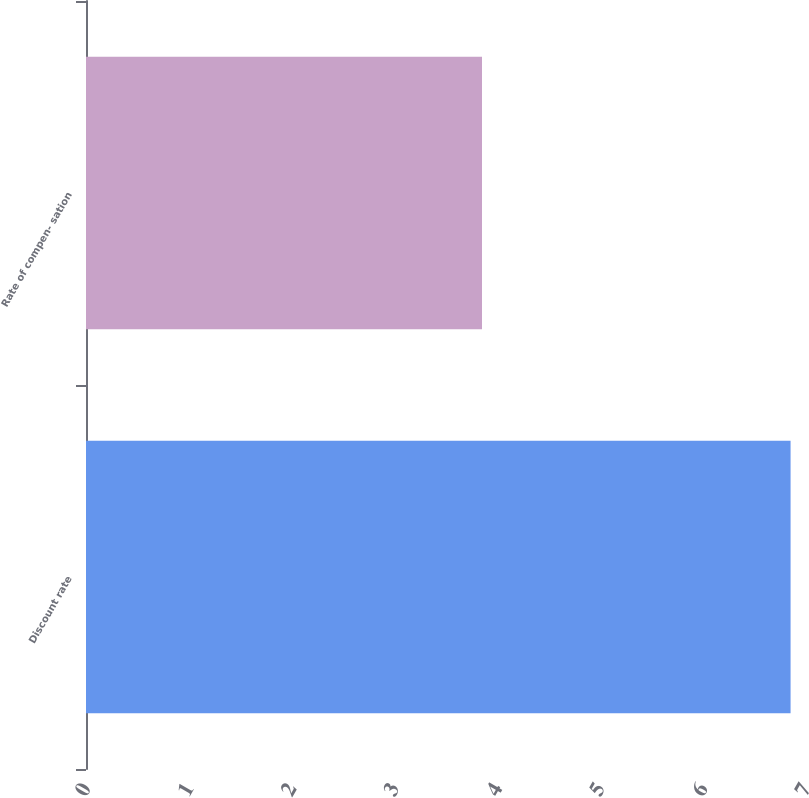Convert chart to OTSL. <chart><loc_0><loc_0><loc_500><loc_500><bar_chart><fcel>Discount rate<fcel>Rate of compen- sation<nl><fcel>6.85<fcel>3.85<nl></chart> 